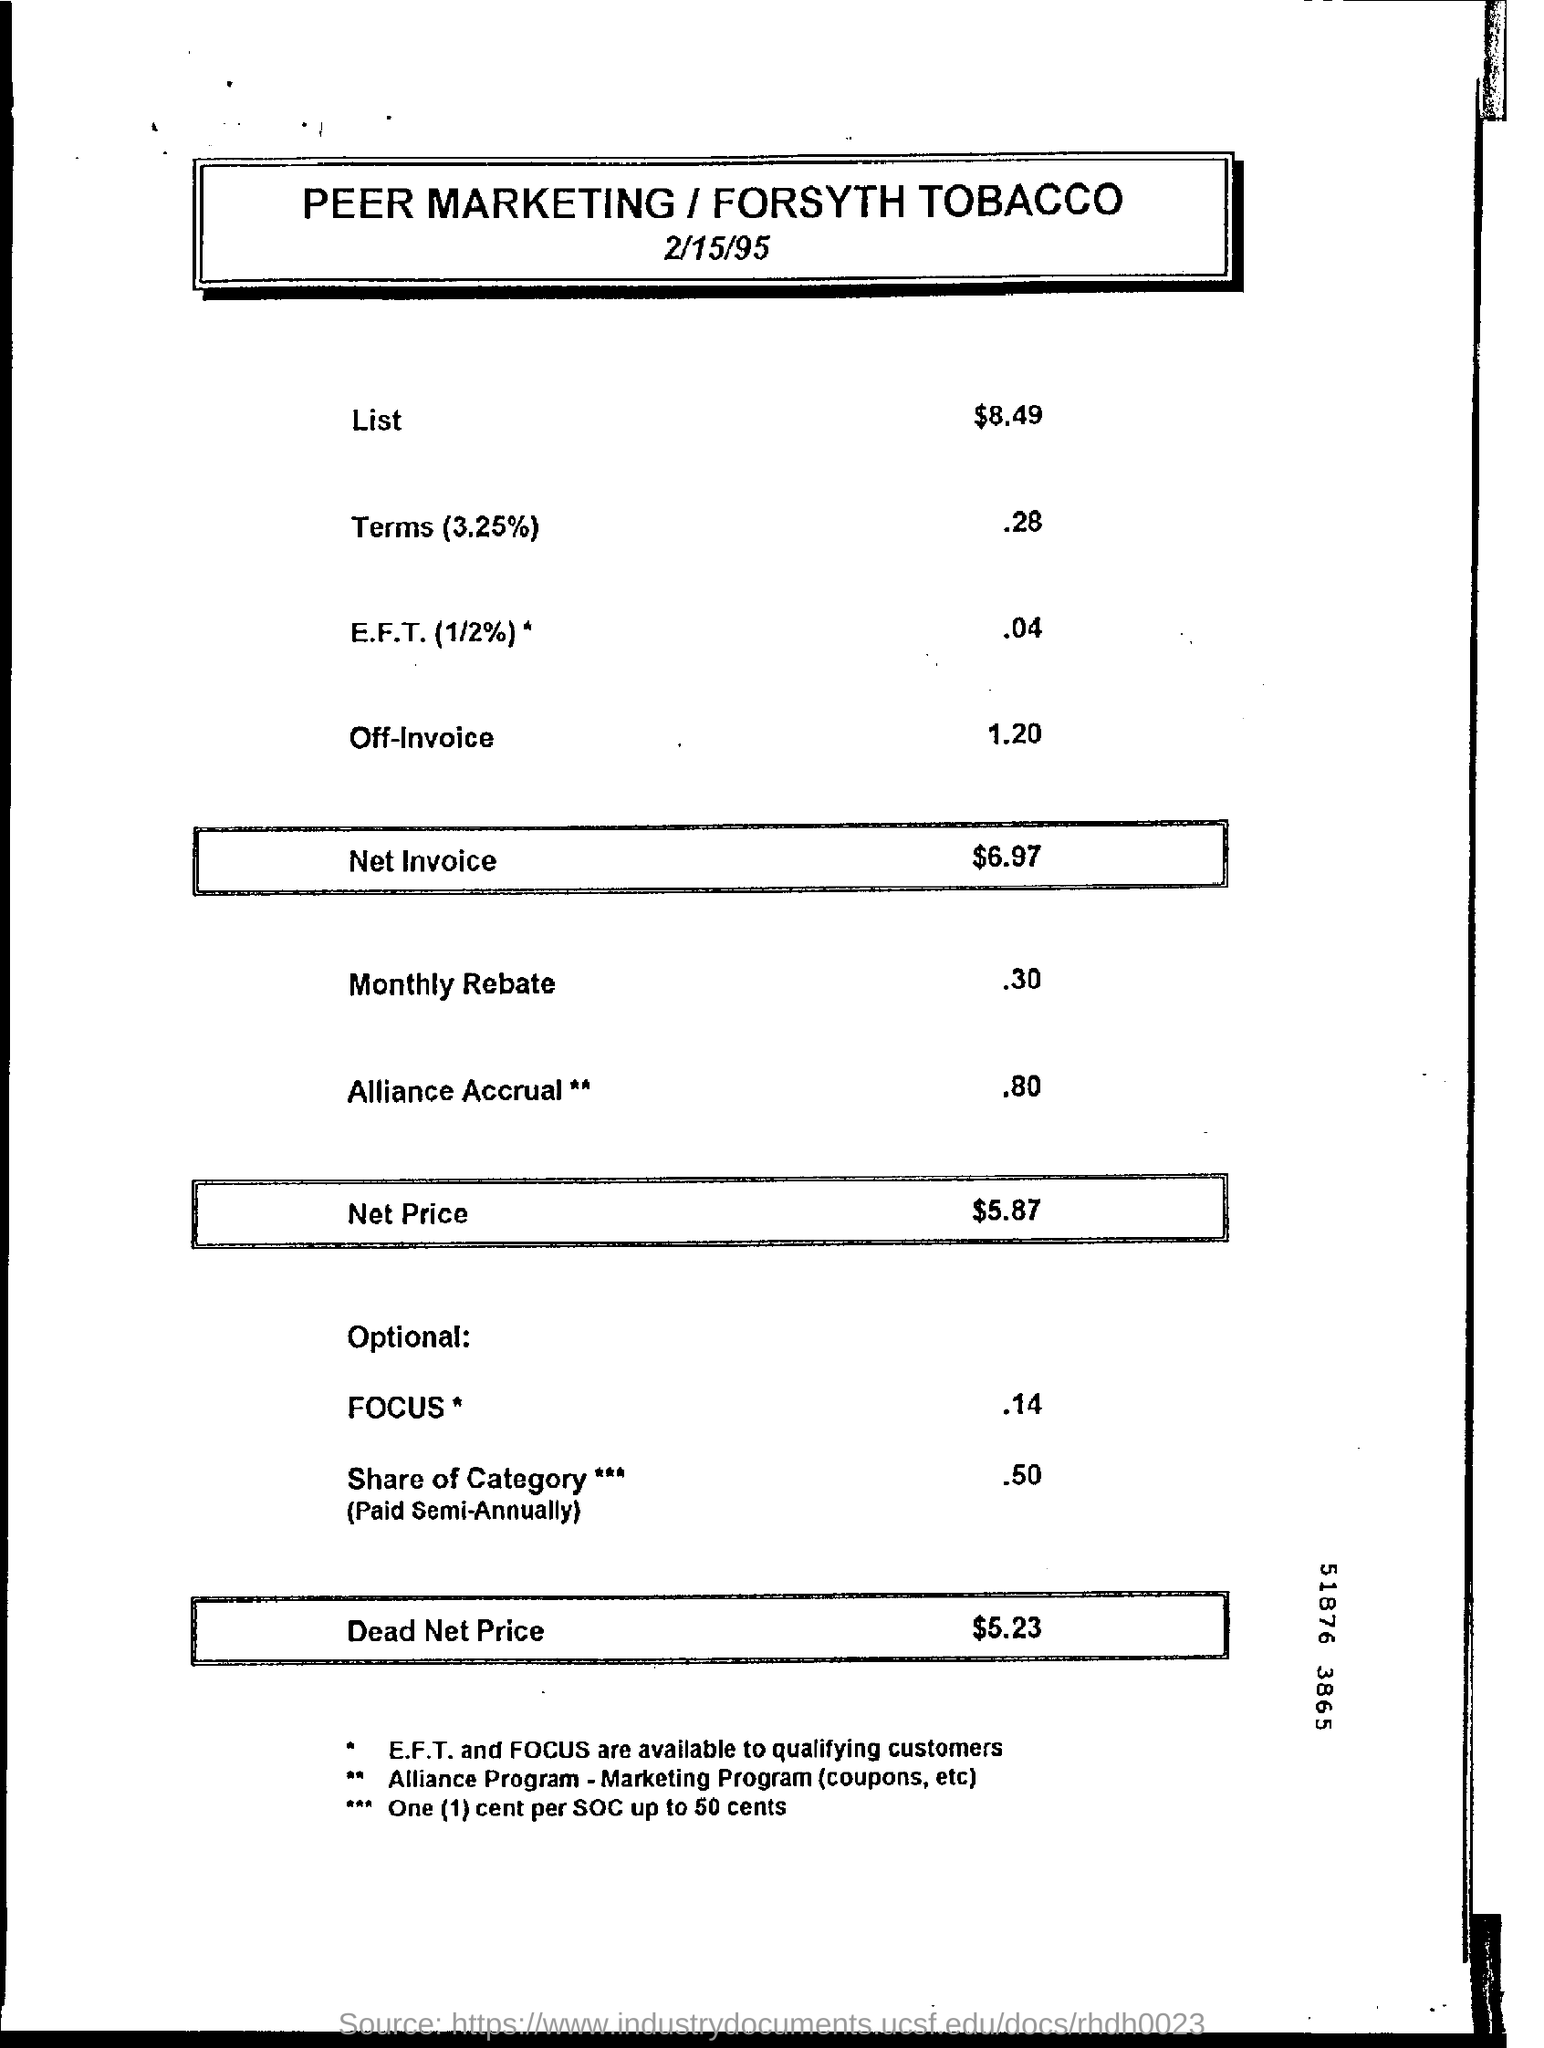Outline some significant characteristics in this image. The dead net price is $5.23. The value mentioned in the List category is $8.49. The net price is $5.87. The monthly rebate is approximately 30 cents. The Net Invoice value is $6.97. 